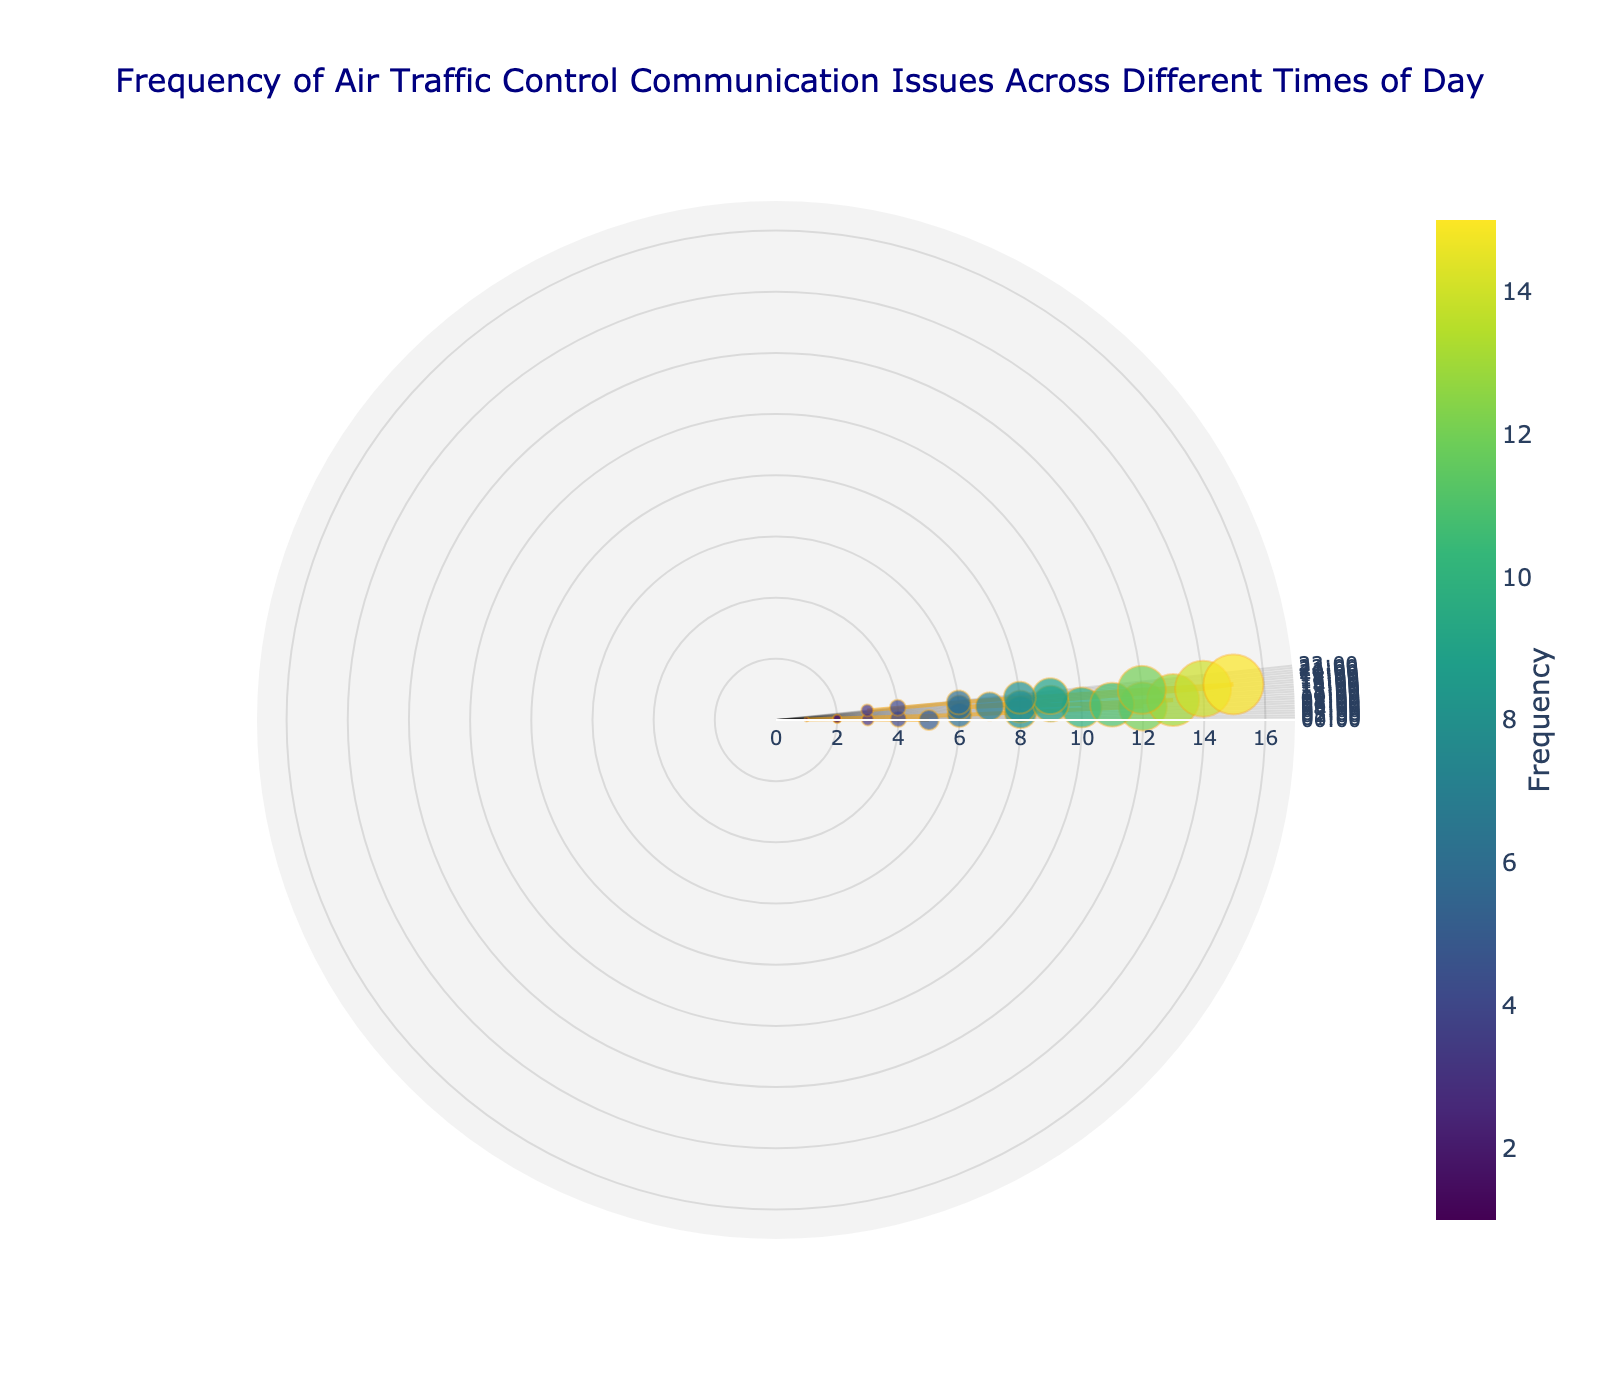What is the title of the plot? The plot's title is provided in the visualization as the main heading, indicating the content of the plot.
Answer: Frequency of Air Traffic Control Communication Issues Across Different Times of Day What is the time with the highest frequency of communication issues? To find this, observe the data point with the largest radius and marker size.
Answer: 17:00 At what time(s) do we see a frequency of 6 communication issues? Identify the markers with a radius that corresponds to 6 issues.
Answer: 06:00, 15:00, 21:00 How does the frequency of communication issues at 09:00 compare to 19:00? Look at the radius of the markers at both times.
Answer: The frequency at 09:00 is greater than at 19:00 What is the average frequency of communication issues between midnight and 06:00? Sum the frequencies from 00:00 to 06:00 and divide by the number of data points (7). Calculation: (5 + 3 + 4 + 2 + 1 + 2 + 6) / 7
Answer: 3.29 Which two consecutive hours have the largest increase in communication issue frequency? Calculate the difference between each pair of consecutive hours and identify the largest. The increase from 11:00 to 12:00 and 16:00 to 17:00 is the largest here.
Answer: 03:00 to 04:00 Does the frequency remain constant at any point of the day? Look for any flat lines or data points with the same frequency.
Answer: No, the frequency changes for all hours At what time do we see the steepest decline in communication issues from one hour to the next? Find the largest decrease between two consecutive points.
Answer: 16:00 to 17:00 What is the general trend of the frequency of communication issues from 06:00 to 12:00? Observe the direction (increase or decrease) of the markers from 06:00 to 12:00.
Answer: Increasing How many hours have a communication issue frequency of at least 10? Count the markers with a radius corresponding to 10 or more issues.
Answer: 5 